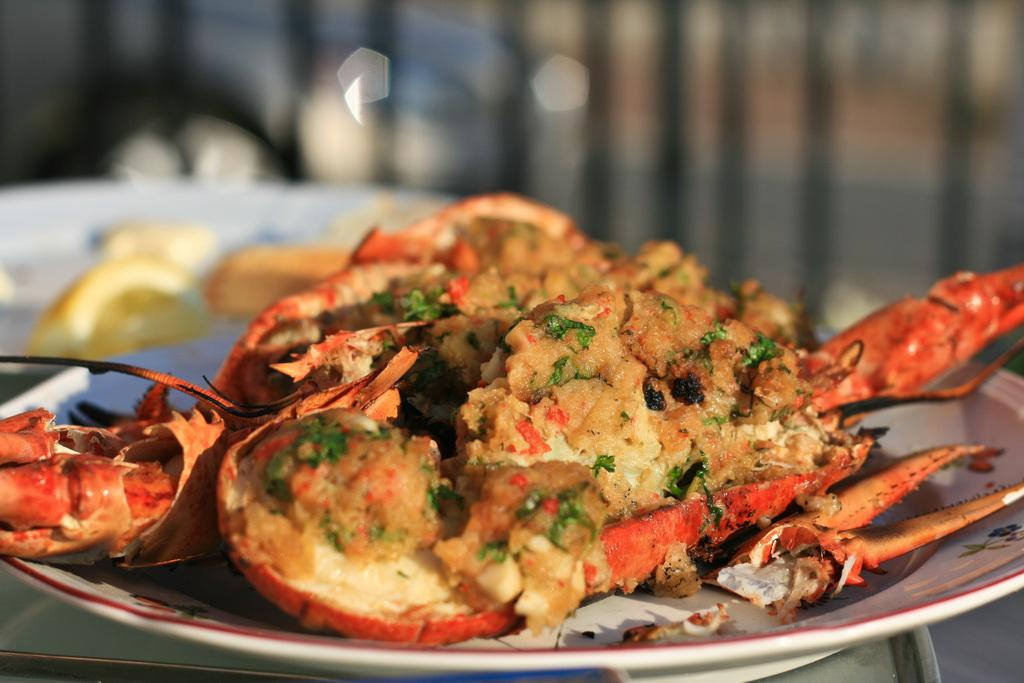What object is present on the plate in the image? There is food on the plate in the image. Can you describe the background of the image? The background of the image is blurry. What type of baseball is being used in the image? There is no baseball present in the image. Is there a balloon visible in the image? There is no balloon present in the image. 